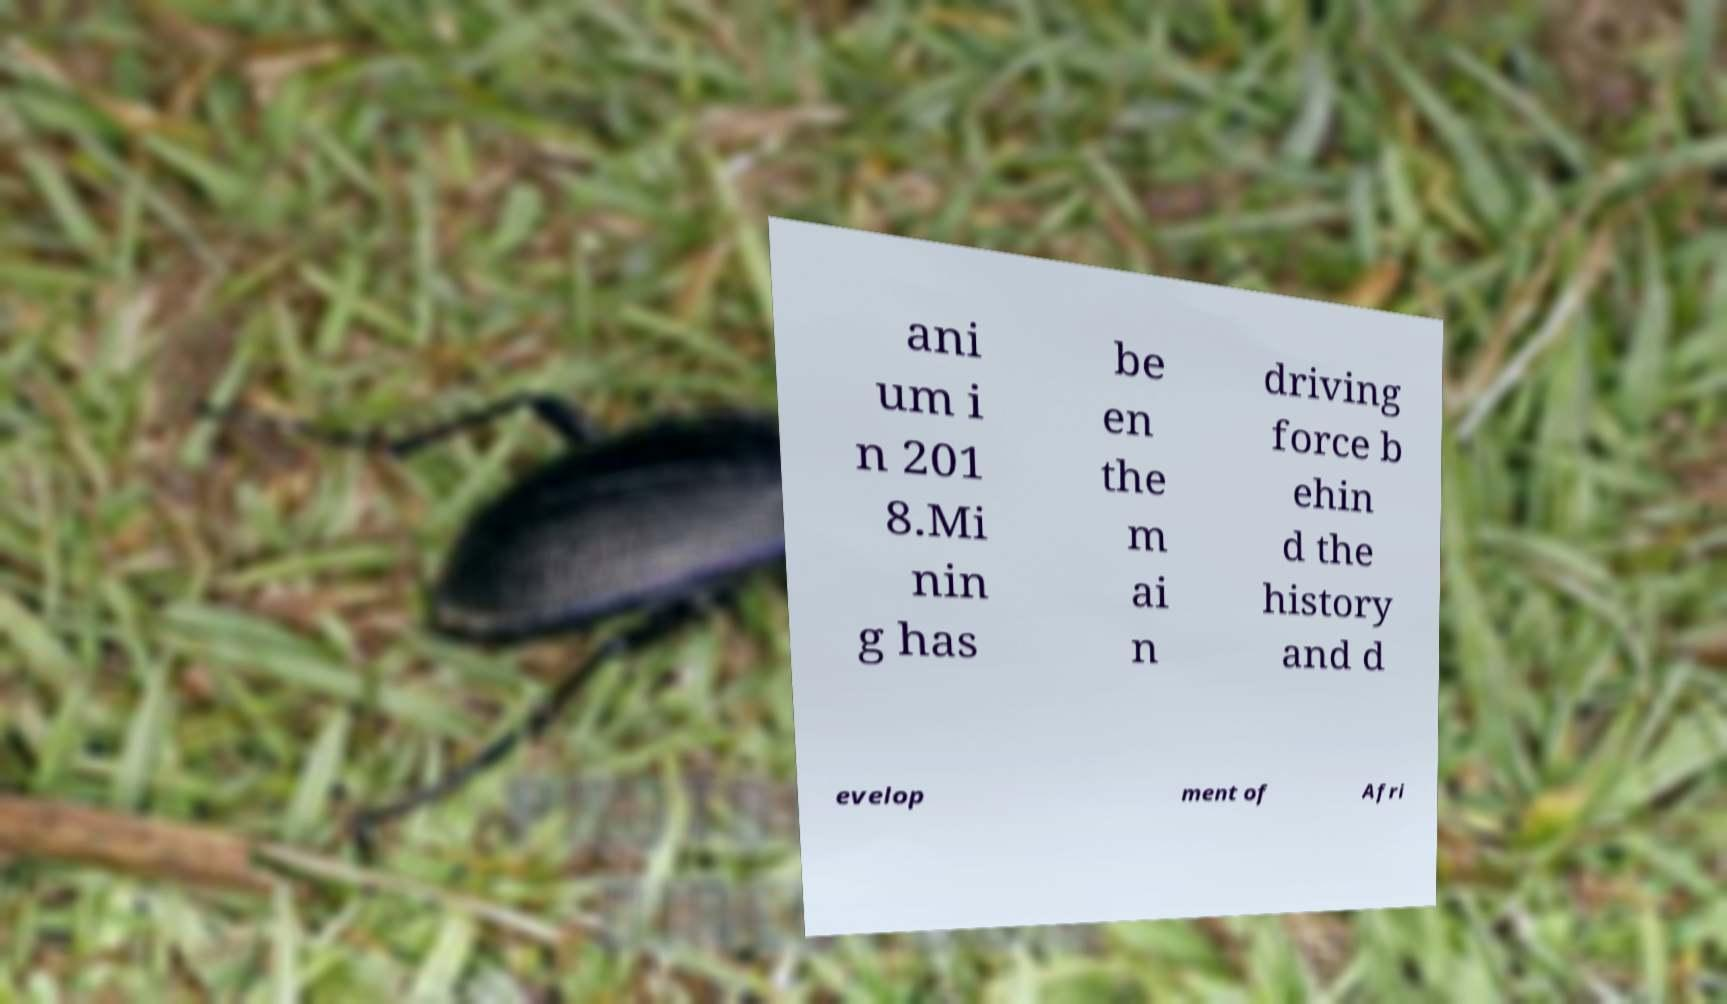Please identify and transcribe the text found in this image. ani um i n 201 8.Mi nin g has be en the m ai n driving force b ehin d the history and d evelop ment of Afri 